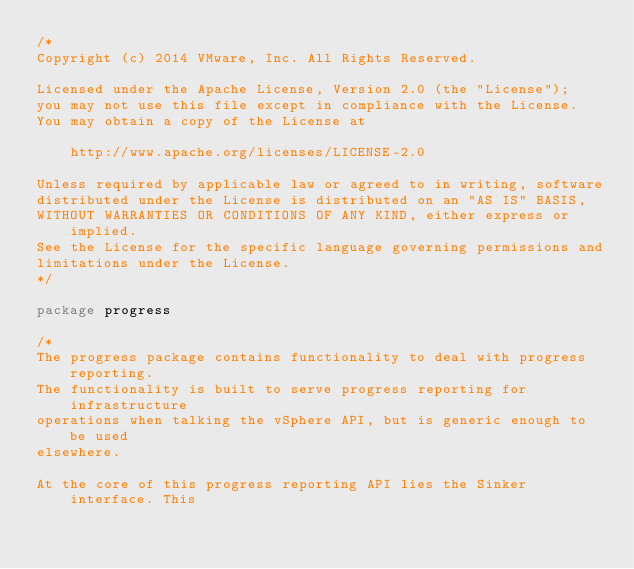Convert code to text. <code><loc_0><loc_0><loc_500><loc_500><_Go_>/*
Copyright (c) 2014 VMware, Inc. All Rights Reserved.

Licensed under the Apache License, Version 2.0 (the "License");
you may not use this file except in compliance with the License.
You may obtain a copy of the License at

    http://www.apache.org/licenses/LICENSE-2.0

Unless required by applicable law or agreed to in writing, software
distributed under the License is distributed on an "AS IS" BASIS,
WITHOUT WARRANTIES OR CONDITIONS OF ANY KIND, either express or implied.
See the License for the specific language governing permissions and
limitations under the License.
*/

package progress

/*
The progress package contains functionality to deal with progress reporting.
The functionality is built to serve progress reporting for infrastructure
operations when talking the vSphere API, but is generic enough to be used
elsewhere.

At the core of this progress reporting API lies the Sinker interface. This</code> 